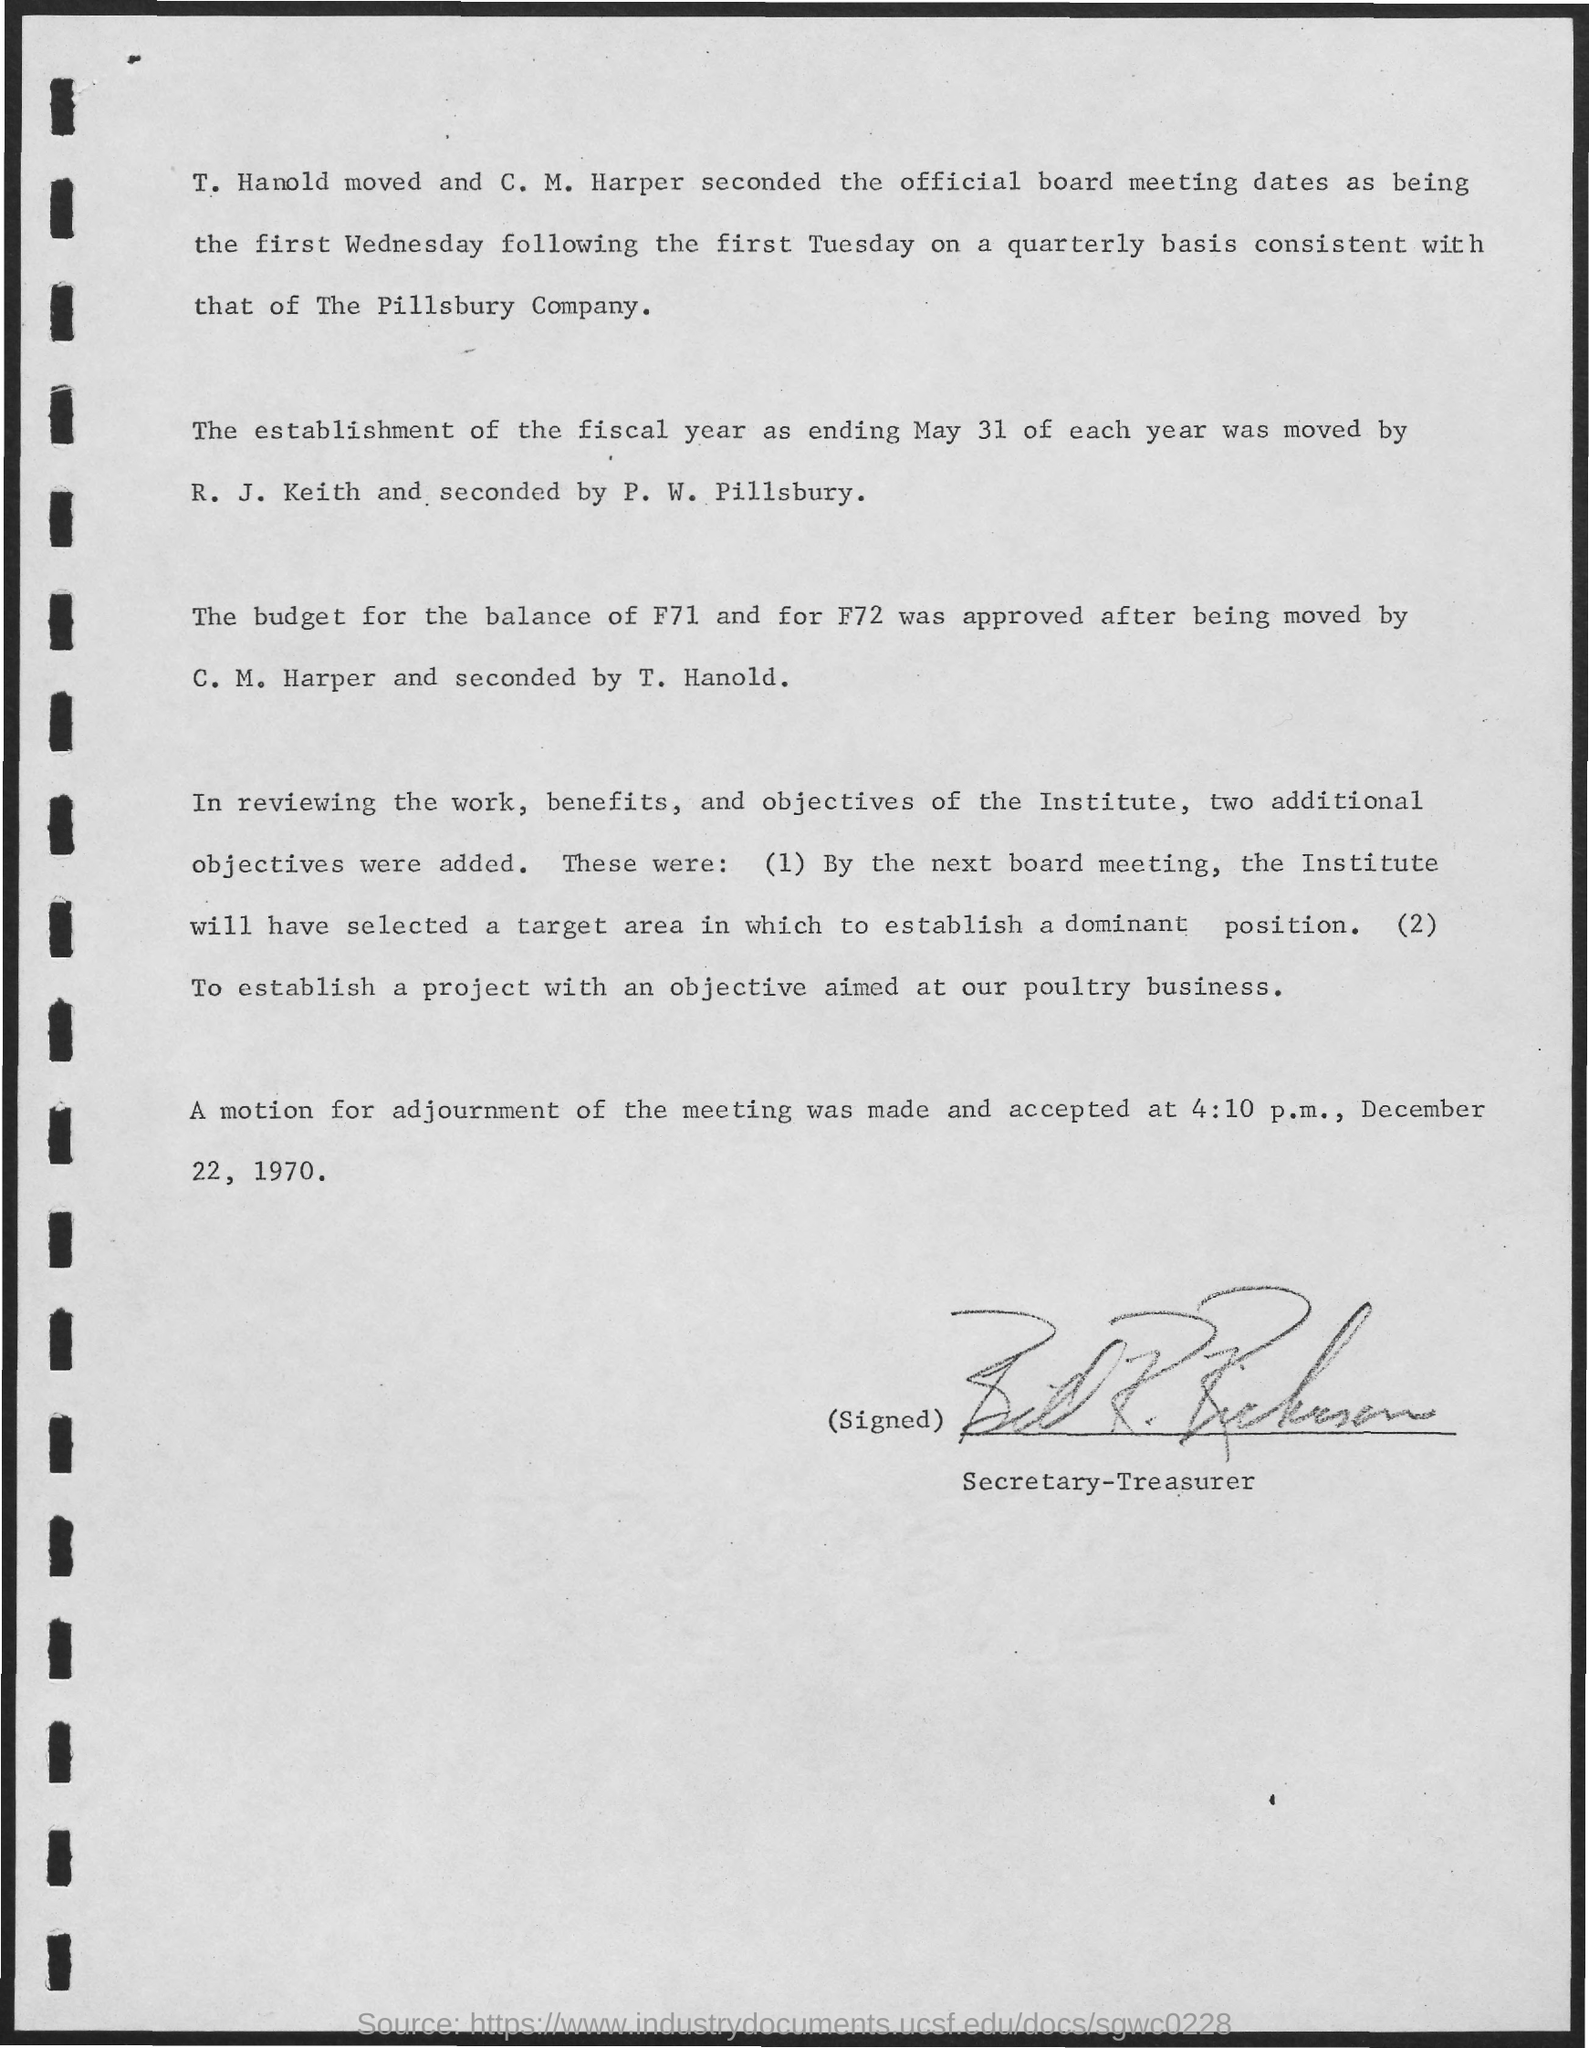What is the date mentioned at the bottom of the document?
Keep it short and to the point. December 22, 1970. What is the time mentioned in the document?
Your response must be concise. 4:10 p.m. 